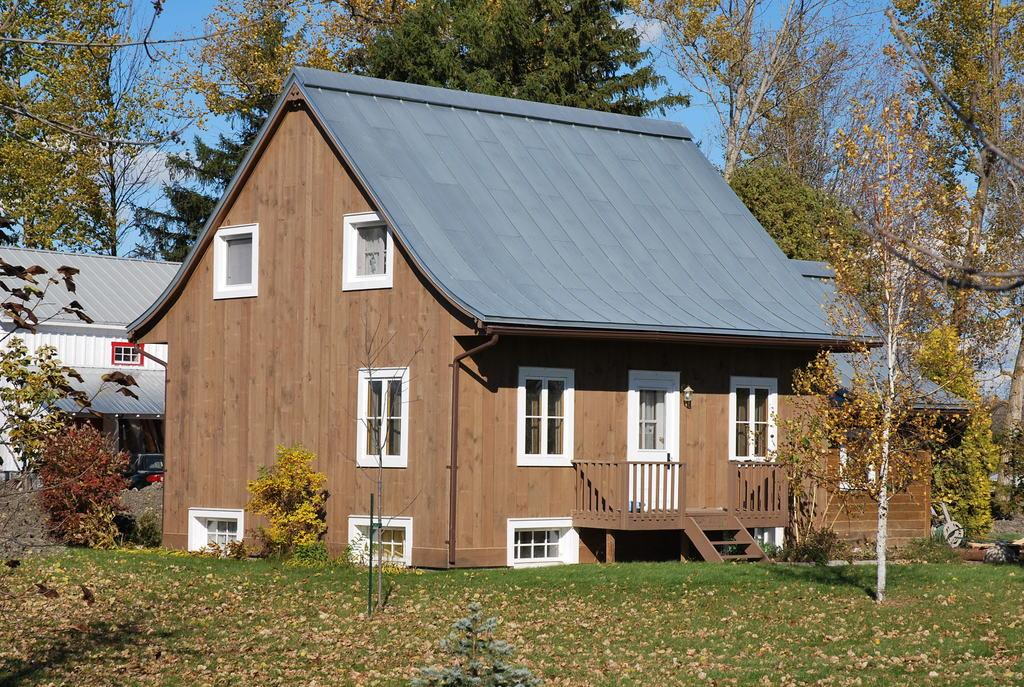What type of vegetation is present in the image? There is grass and plants in the image. What is the main structure in the image? There is a house at the center of the image. Can you describe the house in the image? The house has windows and a white door. What other features can be seen in the image? There is a fence and stairs at the right side of the image. What can be seen in the background of the image? There are other houses and trees in the background of the image. How many children are wearing jeans in the image? There are no children or jeans present in the image. What type of weather can be seen in the image? The provided facts do not mention any weather conditions, so it cannot be determined from the image. 